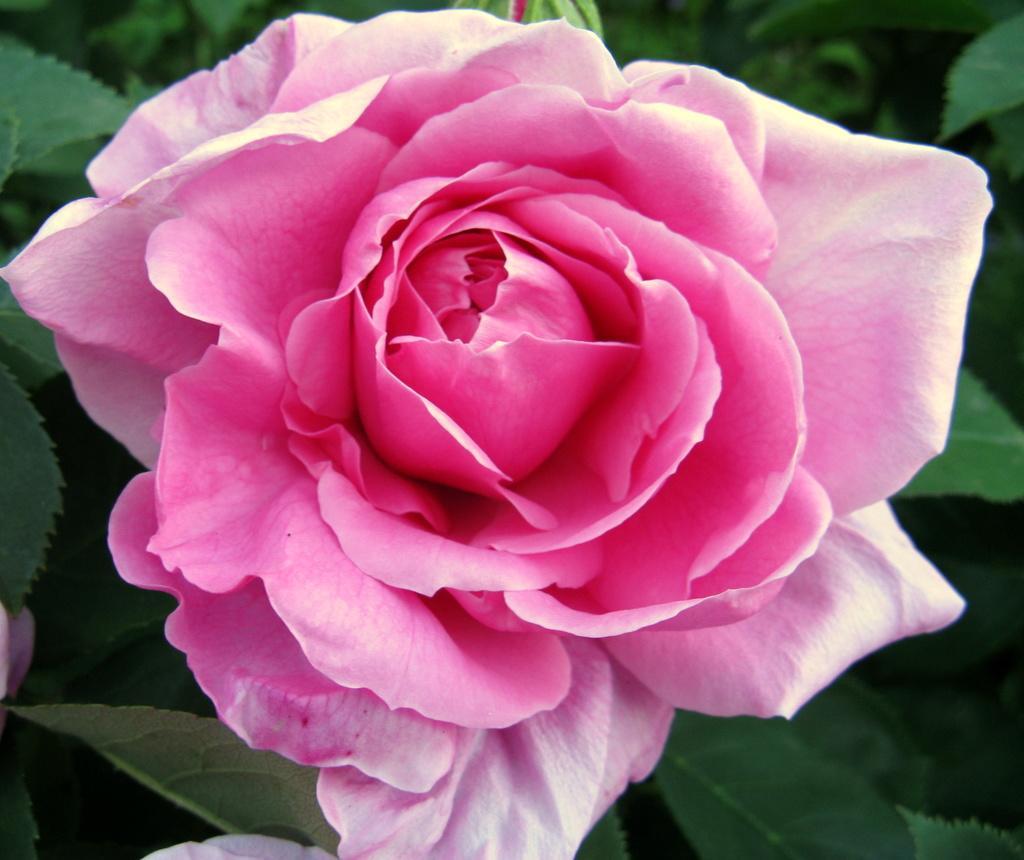Can you describe this image briefly? In this picture there is a pink color rose on the plant. At the back there is a bud on the plant. 